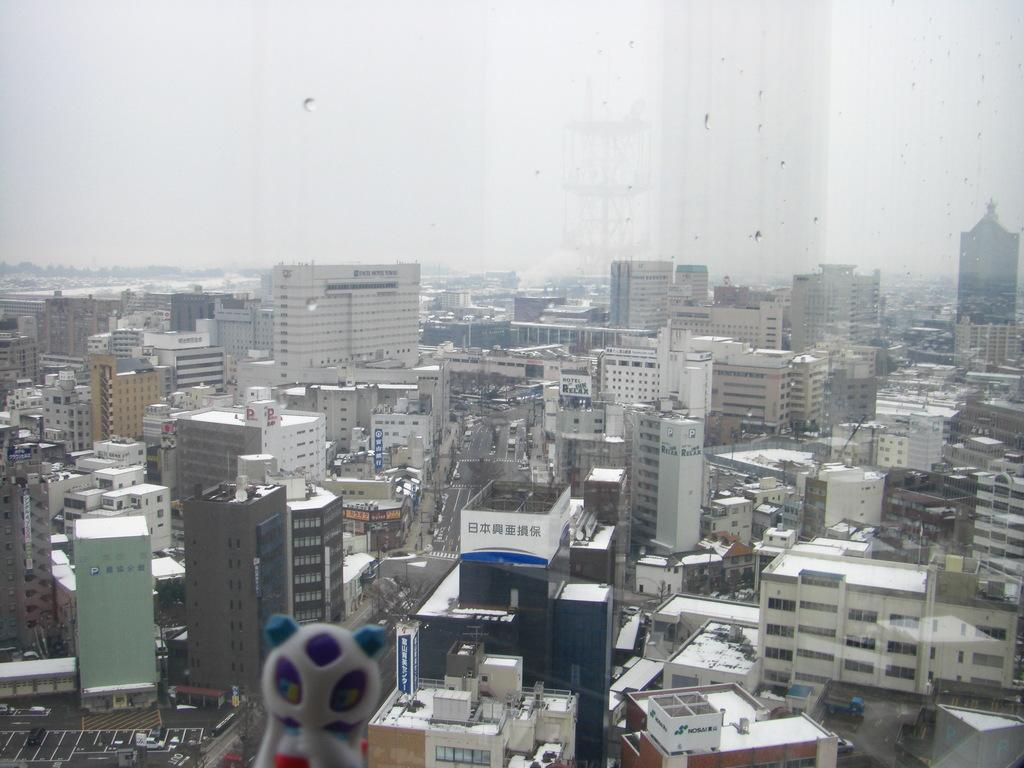What is the main feature of the image? There are many buildings in the image. Can you describe the road in the image? There is a road at the center of the image. What type of protest is happening on the sidewalk in the image? There is no protest or sidewalk present in the image; it only features buildings and a road. 